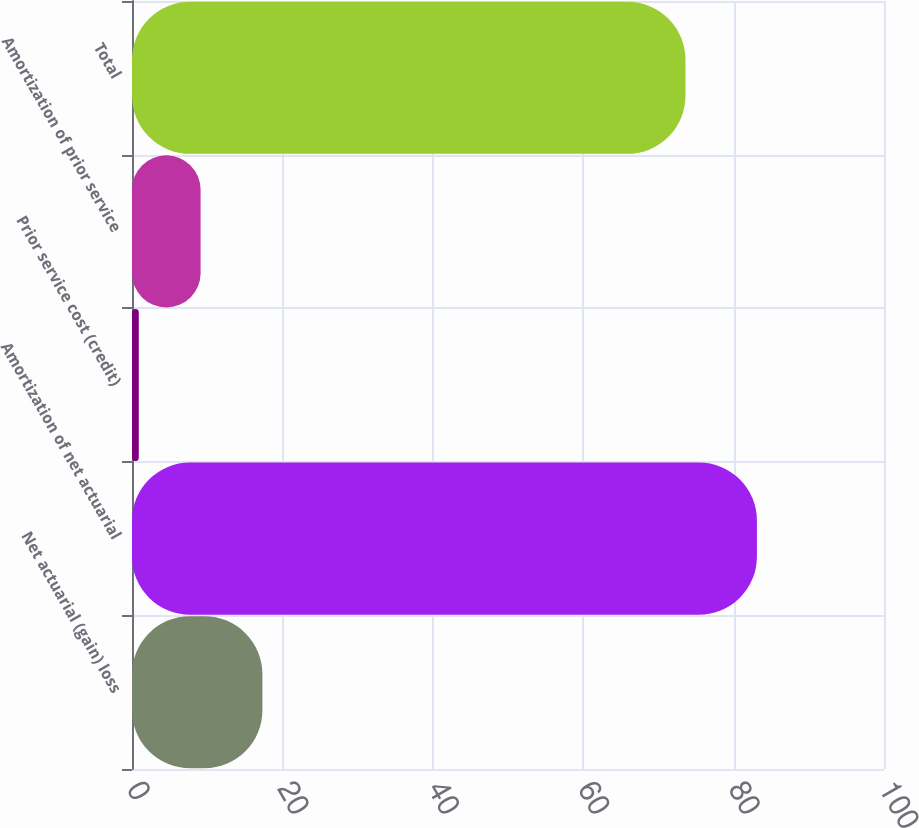<chart> <loc_0><loc_0><loc_500><loc_500><bar_chart><fcel>Net actuarial (gain) loss<fcel>Amortization of net actuarial<fcel>Prior service cost (credit)<fcel>Amortization of prior service<fcel>Total<nl><fcel>17.34<fcel>83.1<fcel>0.9<fcel>9.12<fcel>73.6<nl></chart> 